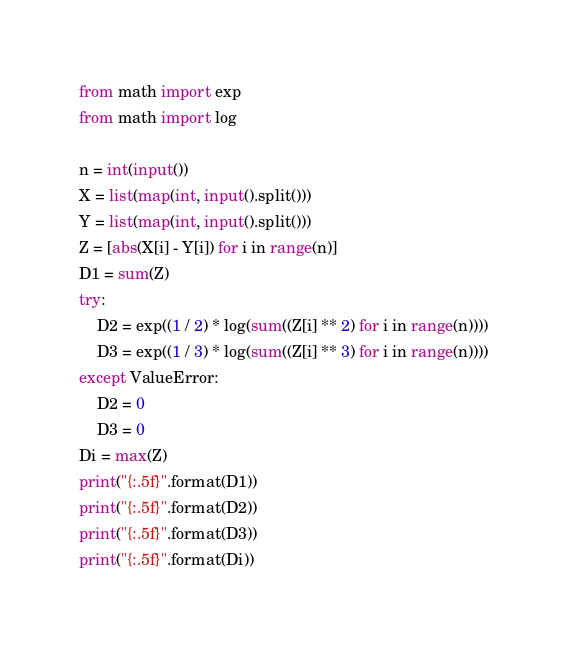Convert code to text. <code><loc_0><loc_0><loc_500><loc_500><_Python_>from math import exp
from math import log

n = int(input())
X = list(map(int, input().split()))
Y = list(map(int, input().split()))
Z = [abs(X[i] - Y[i]) for i in range(n)]
D1 = sum(Z)
try:
    D2 = exp((1 / 2) * log(sum((Z[i] ** 2) for i in range(n))))
    D3 = exp((1 / 3) * log(sum((Z[i] ** 3) for i in range(n))))
except ValueError:
    D2 = 0
    D3 = 0
Di = max(Z)
print("{:.5f}".format(D1))
print("{:.5f}".format(D2))
print("{:.5f}".format(D3))
print("{:.5f}".format(Di))</code> 